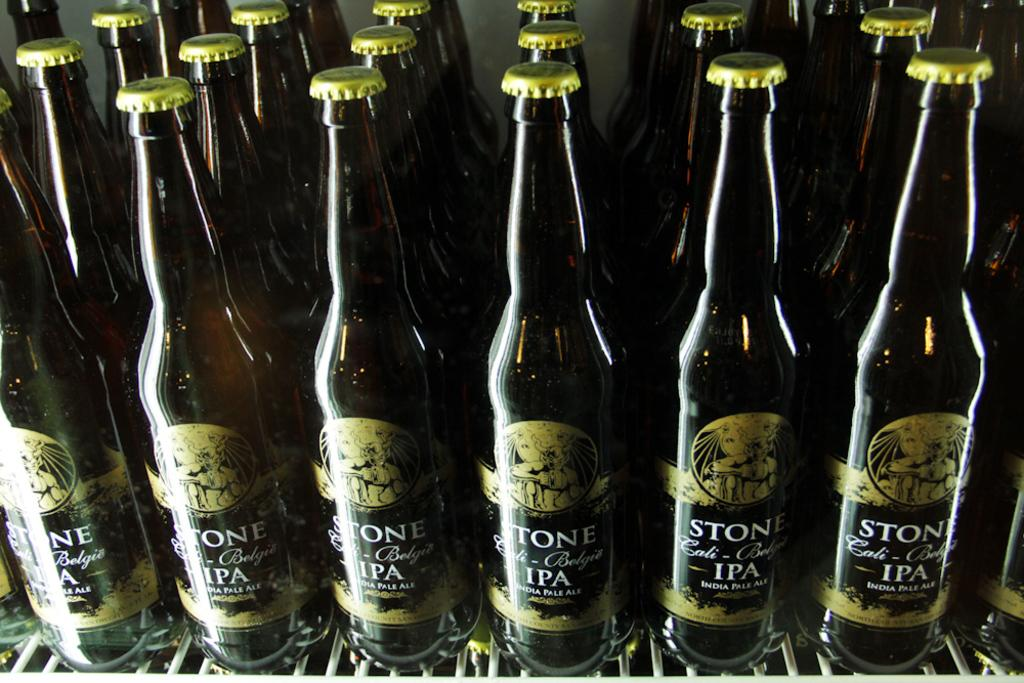<image>
Write a terse but informative summary of the picture. Several bottles of Stone IPA with gold labels and white text lined up on a wire shelf. 